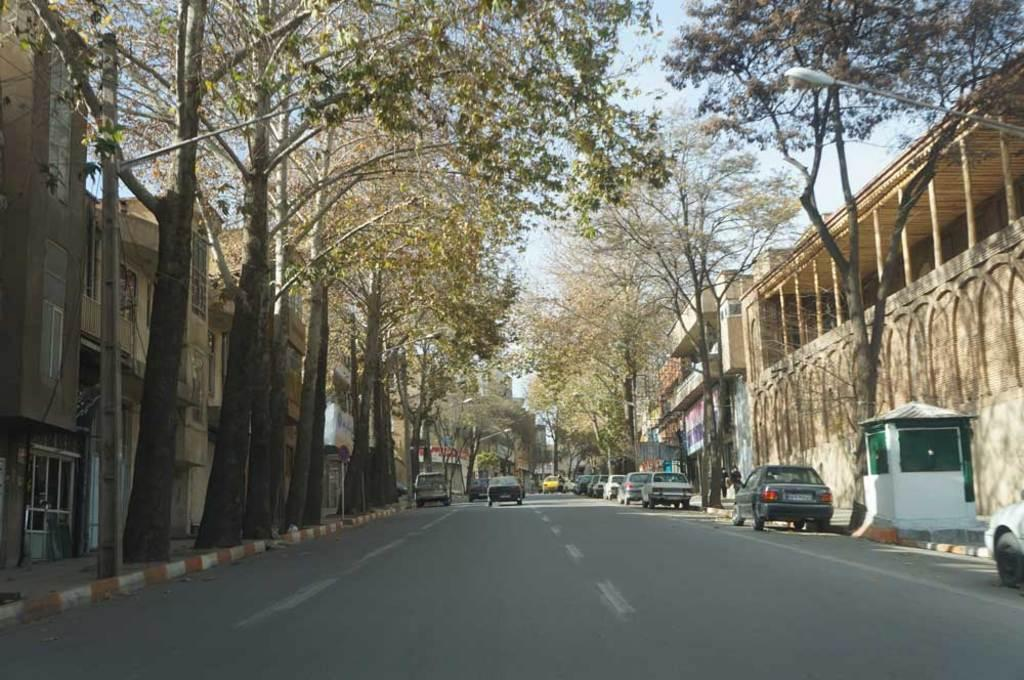What type of structures can be seen in the image? There are buildings in the image. What is happening on the road in the image? There are vehicles on the road in the image. What type of lighting is present in the image? There are pole lights in the image. What type of vegetation is present in the image? There are trees in the image. What can be seen in the background of the image? The sky is visible in the background of the image. Can you see the pen being used by someone in the image? There is no pen present in the image. Are the trees stretching towards the sky in the image? The trees are not depicted as stretching towards the sky in the image; they are stationary. Can you hear the people laughing in the image? There is no sound or indication of laughter in the image. 